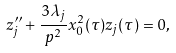Convert formula to latex. <formula><loc_0><loc_0><loc_500><loc_500>\ { z } ^ { \prime \prime } _ { j } + \frac { 3 \lambda _ { j } } { p ^ { 2 } } x _ { 0 } ^ { 2 } ( \tau ) z _ { j } ( \tau ) = 0 ,</formula> 